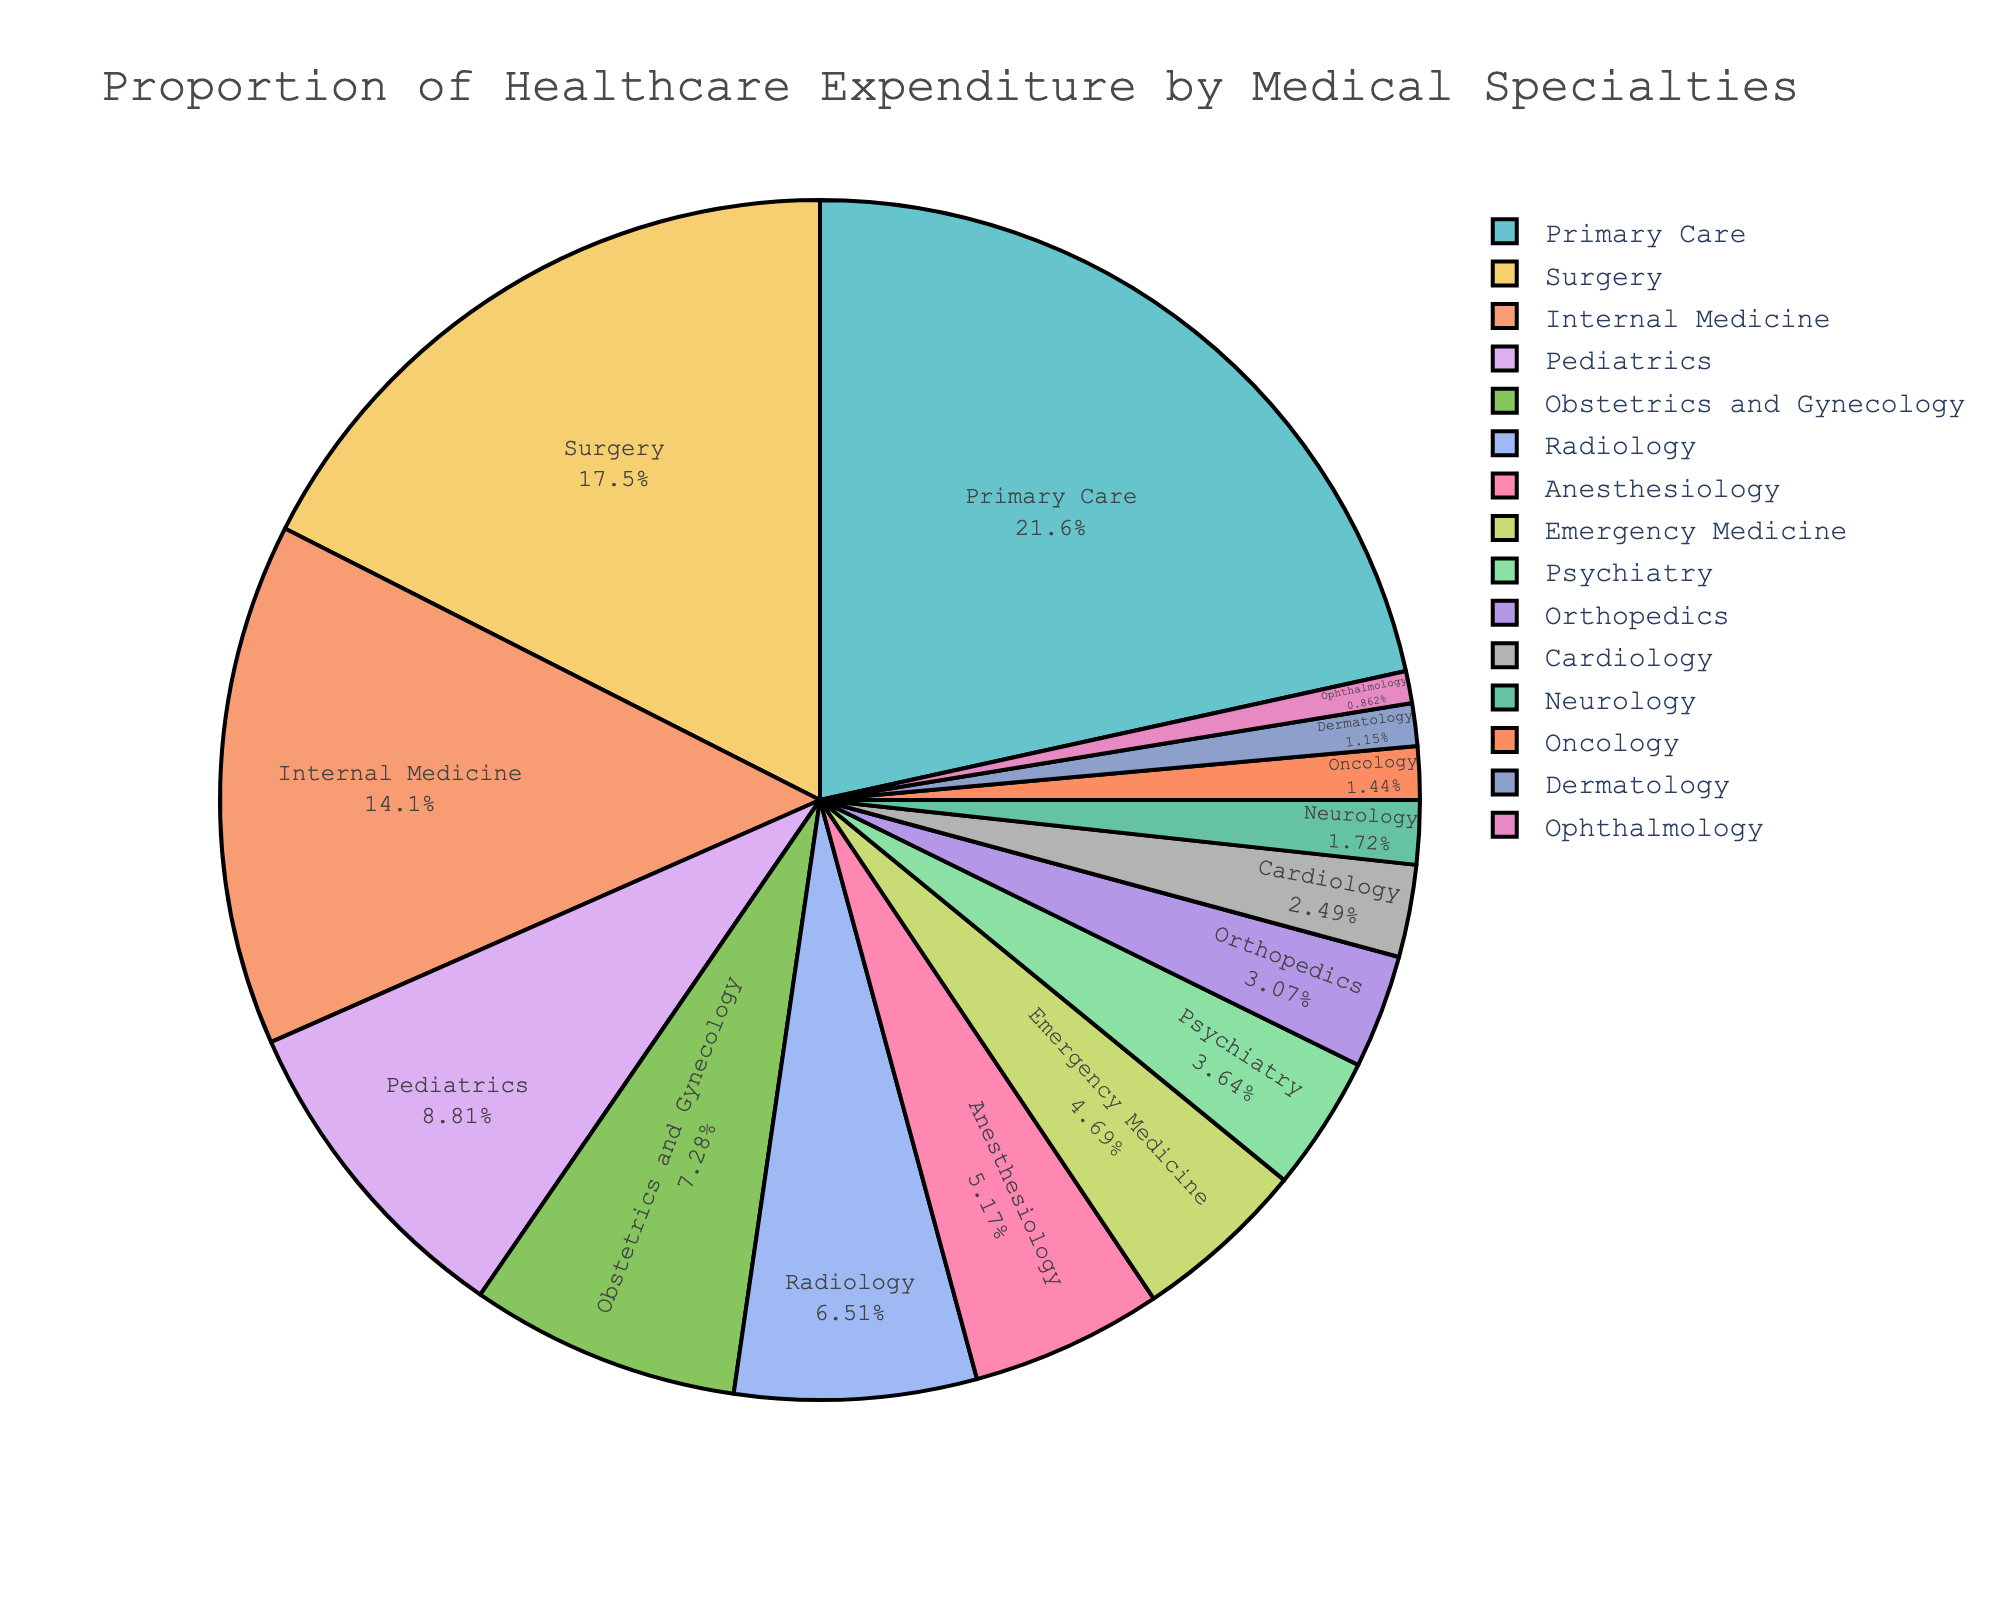What percentage of healthcare expenditure is dedicated to Internal Medicine? Identify the segment labeled "Internal Medicine" on the pie chart and read its associated percentage value.
Answer: 14.7% Which specialty has a higher proportion of healthcare expenditure: Pediatrics or Radiology? Locate the segments labeled "Pediatrics" and "Radiology" on the pie chart and compare their percentages, 9.2% for Pediatrics and 6.8% for Radiology, showing Pediatrics has a higher proportion.
Answer: Pediatrics What is the total percentage of healthcare expenditure for Surgery, Emergency Medicine, and Cardiology combined? Add the percentages for Surgery (18.3%), Emergency Medicine (4.9%), and Cardiology (2.6%): 18.3 + 4.9 + 2.6 = 25.8% of the total expenditure.
Answer: 25.8% How much more is spent on Primary Care compared to Anesthesiology? Find the percentages for Primary Care (22.5%) and Anesthesiology (5.4%), then subtract the latter from the former: 22.5 - 5.4 = 17.1%.
Answer: 17.1% Among Obstetrics and Gynecology, Psychiatry, and Dermatology, which specialty has the smallest proportion of healthcare expenditure? Compare the percentages of Obstetrics and Gynecology (7.6%), Psychiatry (3.8%), and Dermatology (1.2%) and determine that Dermatology has the smallest share.
Answer: Dermatology What is the difference in healthcare expenditure proportions between Orthopedics and Neurology? Find the percentages for Orthopedics (3.2%) and Neurology (1.8%) and subtract the latter from the former: 3.2 - 1.8 = 1.4%.
Answer: 1.4% Are there more funds allocated to Pediatrics or Oncology, and by how much? Compare the percentages for Pediatrics (9.2%) and Oncology (1.5%) and calculate the difference: 9.2 - 1.5 = 7.7%.
Answer: Pediatrics, by 7.7% Which two specialties combined make up approximately one-third of the total healthcare expenditure? Sum the percentages to find pairs that total to about one-third (33.3%). Surgery (18.3%) and Internal Medicine (14.7%) add up to 33.0%.
Answer: Surgery and Internal Medicine 